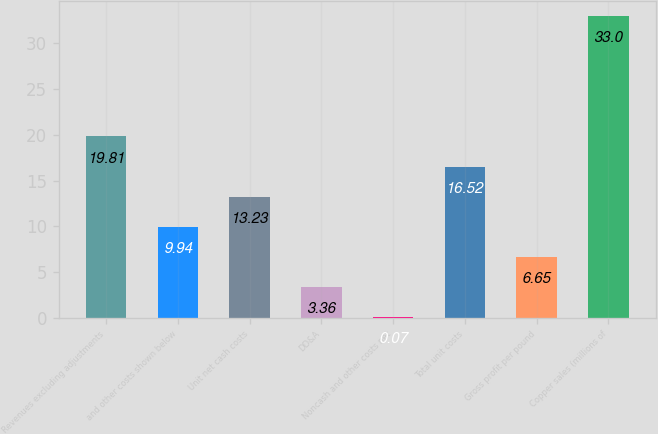Convert chart to OTSL. <chart><loc_0><loc_0><loc_500><loc_500><bar_chart><fcel>Revenues excluding adjustments<fcel>and other costs shown below<fcel>Unit net cash costs<fcel>DD&A<fcel>Noncash and other costs net<fcel>Total unit costs<fcel>Gross profit per pound<fcel>Copper sales (millions of<nl><fcel>19.81<fcel>9.94<fcel>13.23<fcel>3.36<fcel>0.07<fcel>16.52<fcel>6.65<fcel>33<nl></chart> 